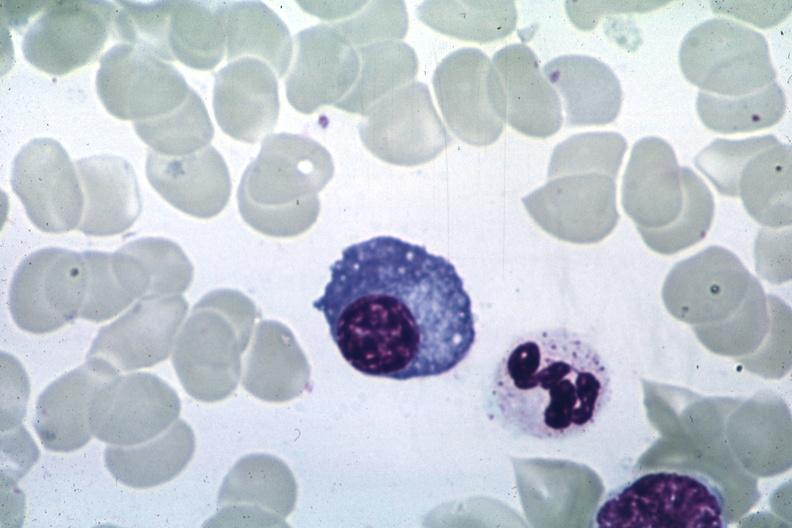s plasma cell present?
Answer the question using a single word or phrase. Yes 